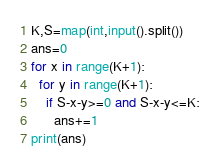<code> <loc_0><loc_0><loc_500><loc_500><_Python_>K,S=map(int,input().split())
ans=0
for x in range(K+1):
  for y in range(K+1):
    if S-x-y>=0 and S-x-y<=K:
      ans+=1
print(ans)</code> 